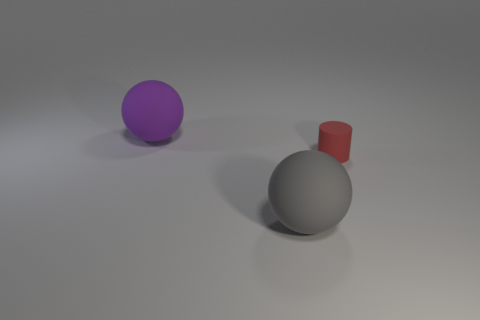How many objects are both in front of the red object and behind the large gray rubber sphere?
Offer a terse response. 0. Are there any other things that have the same shape as the tiny thing?
Provide a short and direct response. No. What number of other objects are there of the same size as the purple object?
Give a very brief answer. 1. There is a sphere that is right of the large purple thing; is it the same size as the matte object to the right of the gray object?
Provide a succinct answer. No. What number of objects are purple metal objects or things left of the red cylinder?
Ensure brevity in your answer.  2. There is a rubber sphere that is in front of the small thing; what is its size?
Keep it short and to the point. Large. Are there fewer gray matte objects that are on the right side of the red rubber object than big balls left of the big purple thing?
Provide a short and direct response. No. There is a thing that is behind the gray thing and to the left of the matte cylinder; what material is it made of?
Give a very brief answer. Rubber. There is a big rubber thing behind the matte thing in front of the tiny red cylinder; what shape is it?
Provide a short and direct response. Sphere. What number of brown objects are spheres or rubber things?
Provide a short and direct response. 0. 